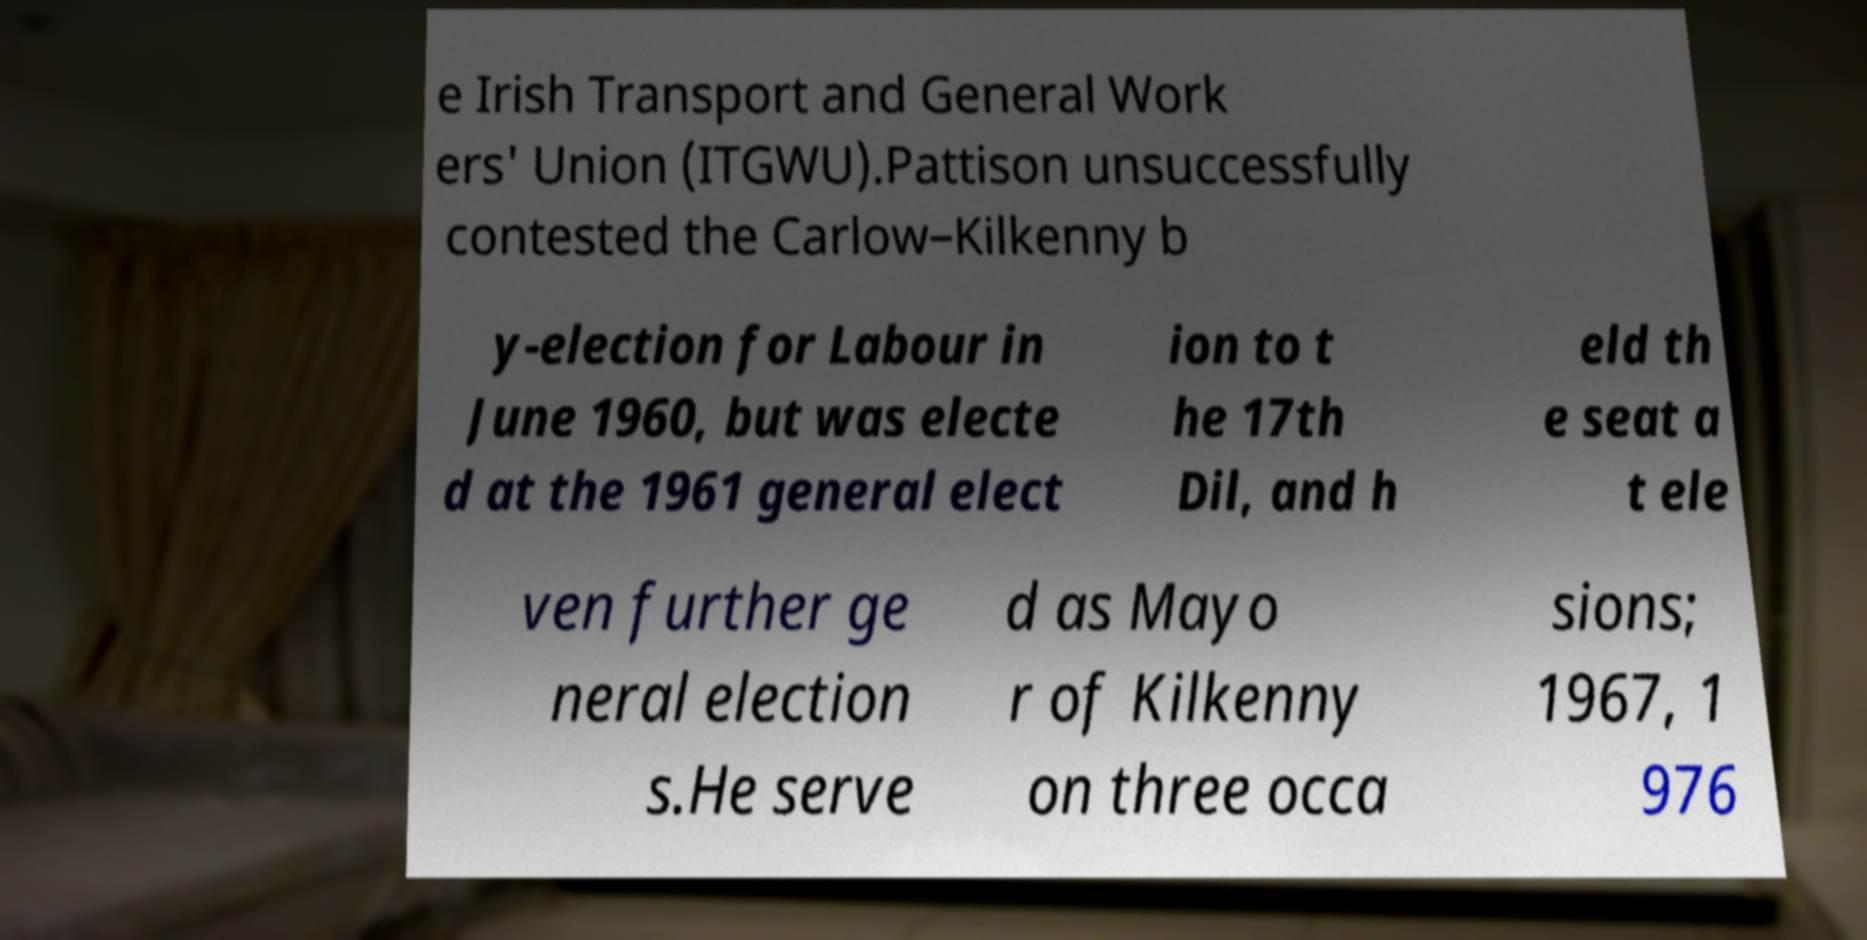For documentation purposes, I need the text within this image transcribed. Could you provide that? e Irish Transport and General Work ers' Union (ITGWU).Pattison unsuccessfully contested the Carlow–Kilkenny b y-election for Labour in June 1960, but was electe d at the 1961 general elect ion to t he 17th Dil, and h eld th e seat a t ele ven further ge neral election s.He serve d as Mayo r of Kilkenny on three occa sions; 1967, 1 976 